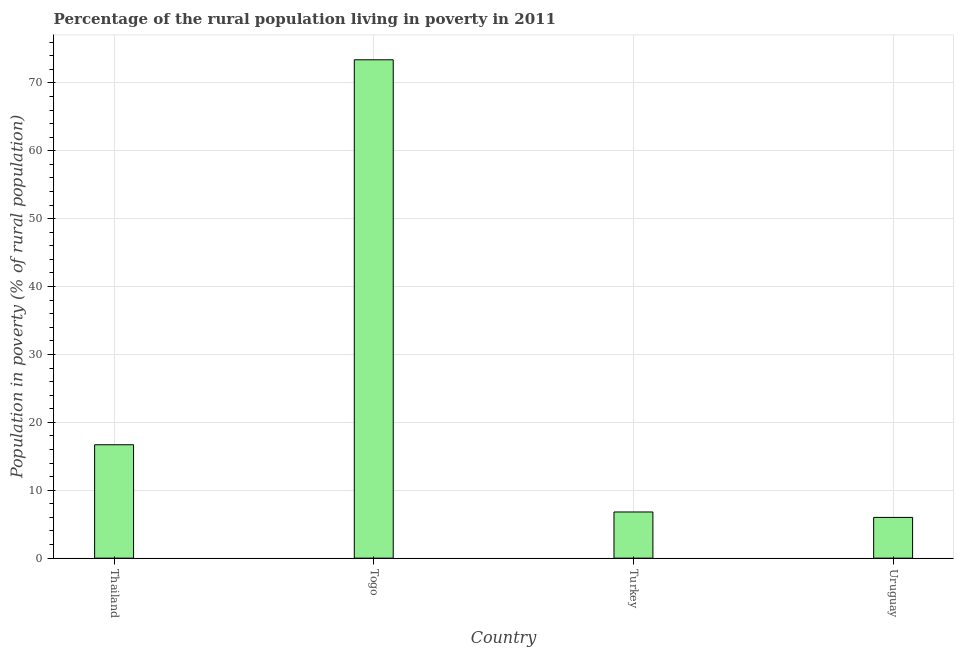Does the graph contain grids?
Your response must be concise. Yes. What is the title of the graph?
Ensure brevity in your answer.  Percentage of the rural population living in poverty in 2011. What is the label or title of the X-axis?
Your answer should be very brief. Country. What is the label or title of the Y-axis?
Offer a very short reply. Population in poverty (% of rural population). Across all countries, what is the maximum percentage of rural population living below poverty line?
Your response must be concise. 73.4. Across all countries, what is the minimum percentage of rural population living below poverty line?
Ensure brevity in your answer.  6. In which country was the percentage of rural population living below poverty line maximum?
Ensure brevity in your answer.  Togo. In which country was the percentage of rural population living below poverty line minimum?
Give a very brief answer. Uruguay. What is the sum of the percentage of rural population living below poverty line?
Provide a short and direct response. 102.9. What is the difference between the percentage of rural population living below poverty line in Togo and Turkey?
Provide a short and direct response. 66.6. What is the average percentage of rural population living below poverty line per country?
Make the answer very short. 25.73. What is the median percentage of rural population living below poverty line?
Make the answer very short. 11.75. What is the ratio of the percentage of rural population living below poverty line in Togo to that in Turkey?
Ensure brevity in your answer.  10.79. Is the difference between the percentage of rural population living below poverty line in Turkey and Uruguay greater than the difference between any two countries?
Provide a short and direct response. No. What is the difference between the highest and the second highest percentage of rural population living below poverty line?
Ensure brevity in your answer.  56.7. What is the difference between the highest and the lowest percentage of rural population living below poverty line?
Keep it short and to the point. 67.4. How many countries are there in the graph?
Keep it short and to the point. 4. What is the Population in poverty (% of rural population) in Togo?
Your answer should be very brief. 73.4. What is the Population in poverty (% of rural population) of Uruguay?
Keep it short and to the point. 6. What is the difference between the Population in poverty (% of rural population) in Thailand and Togo?
Offer a very short reply. -56.7. What is the difference between the Population in poverty (% of rural population) in Thailand and Turkey?
Your response must be concise. 9.9. What is the difference between the Population in poverty (% of rural population) in Togo and Turkey?
Give a very brief answer. 66.6. What is the difference between the Population in poverty (% of rural population) in Togo and Uruguay?
Provide a short and direct response. 67.4. What is the ratio of the Population in poverty (% of rural population) in Thailand to that in Togo?
Keep it short and to the point. 0.23. What is the ratio of the Population in poverty (% of rural population) in Thailand to that in Turkey?
Your answer should be very brief. 2.46. What is the ratio of the Population in poverty (% of rural population) in Thailand to that in Uruguay?
Keep it short and to the point. 2.78. What is the ratio of the Population in poverty (% of rural population) in Togo to that in Turkey?
Provide a short and direct response. 10.79. What is the ratio of the Population in poverty (% of rural population) in Togo to that in Uruguay?
Give a very brief answer. 12.23. What is the ratio of the Population in poverty (% of rural population) in Turkey to that in Uruguay?
Ensure brevity in your answer.  1.13. 